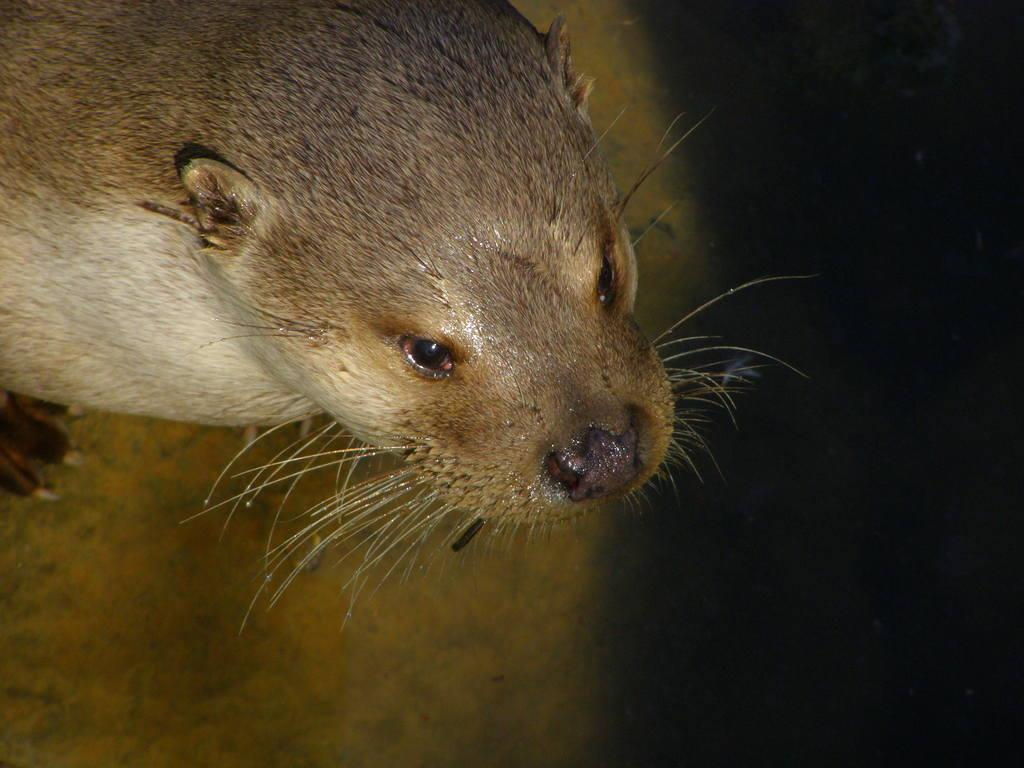What animal is present in the image? There is a seal in the image. How can the lighting conditions be described in the image? The right side of the image is dark. What type of cent is visible on the seal's back in the image? There is no cent present on the seal's back in the image. What suggestion does the seal make to the viewer in the image? The seal does not make any suggestions to the viewer in the image. 